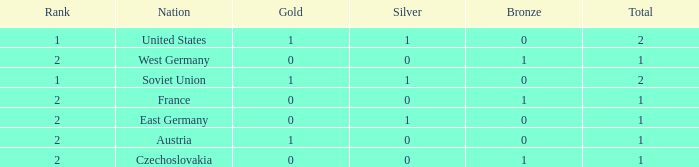What is the rank of the team with 0 gold and less than 0 silvers? None. 